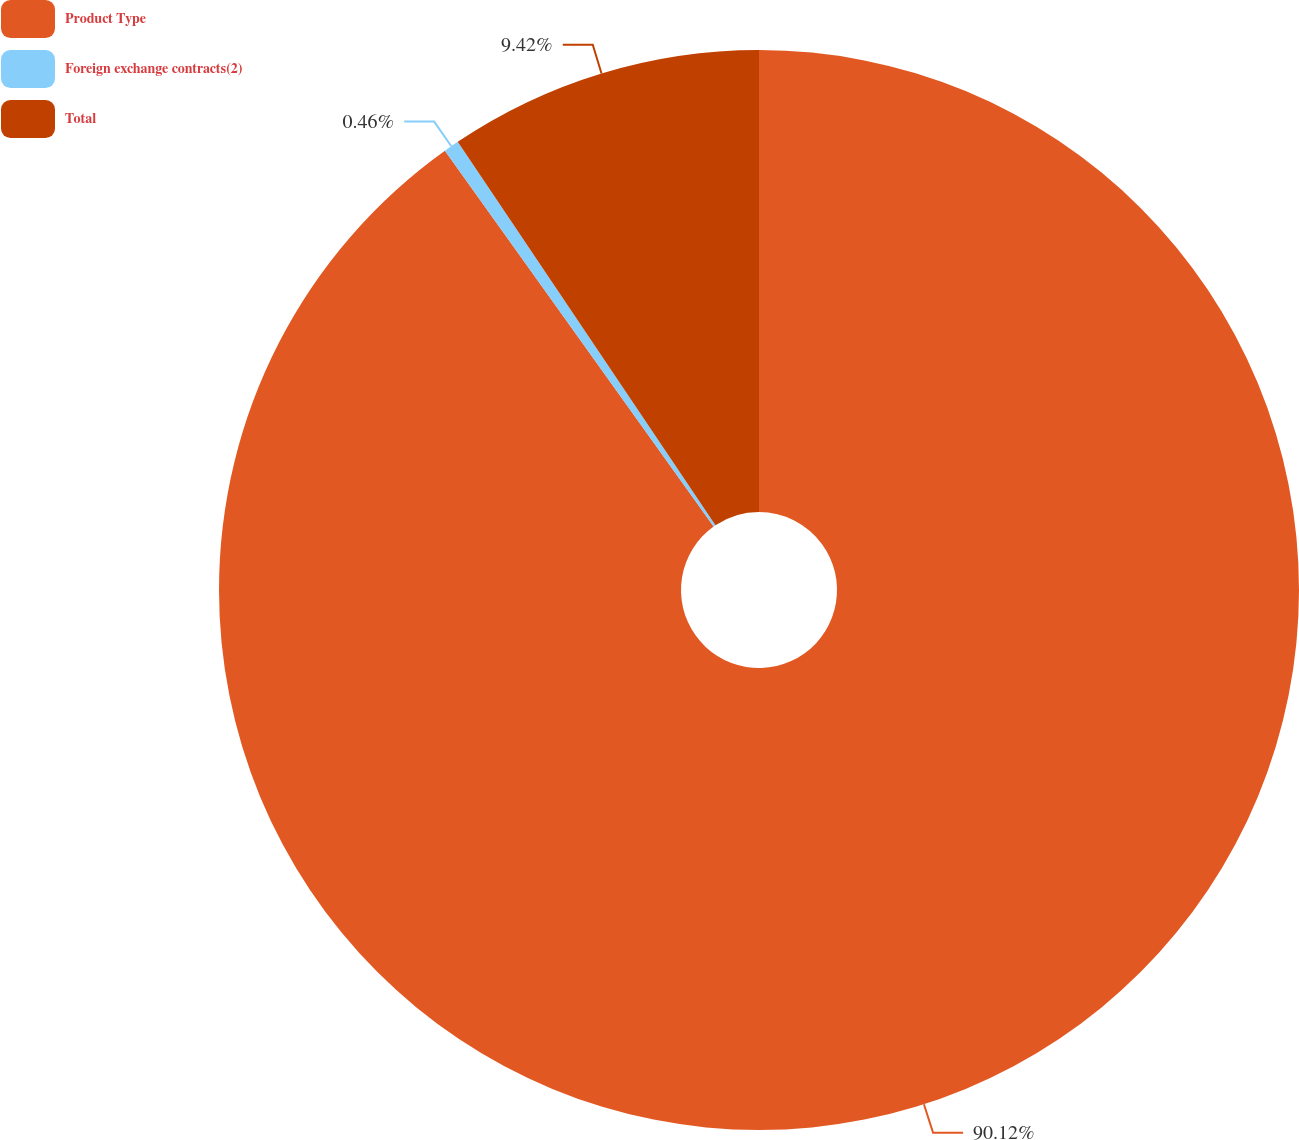Convert chart. <chart><loc_0><loc_0><loc_500><loc_500><pie_chart><fcel>Product Type<fcel>Foreign exchange contracts(2)<fcel>Total<nl><fcel>90.12%<fcel>0.46%<fcel>9.42%<nl></chart> 